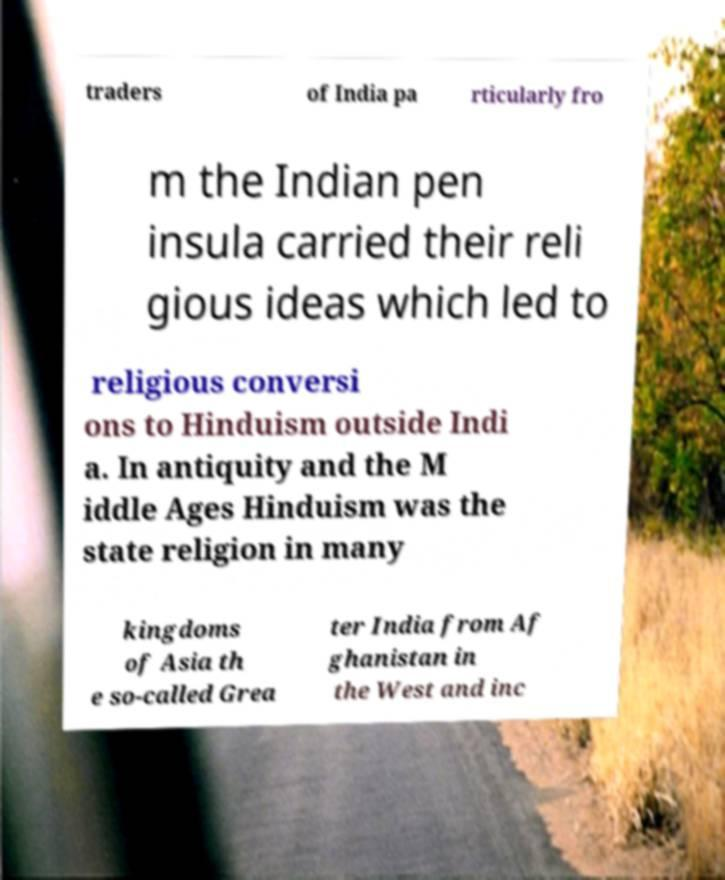Could you extract and type out the text from this image? traders of India pa rticularly fro m the Indian pen insula carried their reli gious ideas which led to religious conversi ons to Hinduism outside Indi a. In antiquity and the M iddle Ages Hinduism was the state religion in many kingdoms of Asia th e so-called Grea ter India from Af ghanistan in the West and inc 